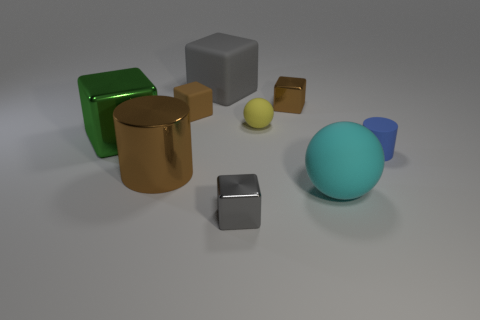Is the color of the big ball the same as the tiny metallic thing behind the cyan rubber sphere?
Offer a very short reply. No. Are there an equal number of big matte cubes in front of the small sphere and big metallic cylinders?
Make the answer very short. No. What number of gray things have the same size as the cyan sphere?
Keep it short and to the point. 1. The shiny object that is the same color as the large cylinder is what shape?
Make the answer very short. Cube. Are any large purple rubber cubes visible?
Make the answer very short. No. There is a big thing behind the brown shiny cube; does it have the same shape as the brown thing that is in front of the tiny ball?
Your answer should be compact. No. How many tiny objects are either gray metal things or red metallic cylinders?
Your response must be concise. 1. There is a gray object that is the same material as the large cylinder; what is its shape?
Offer a very short reply. Cube. Do the large green thing and the yellow rubber object have the same shape?
Ensure brevity in your answer.  No. What is the color of the tiny matte ball?
Provide a short and direct response. Yellow. 